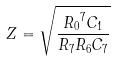<formula> <loc_0><loc_0><loc_500><loc_500>Z = \sqrt { \frac { { R _ { 0 } } ^ { 7 } C _ { 1 } } { R _ { 7 } R _ { 6 } C _ { 7 } } }</formula> 